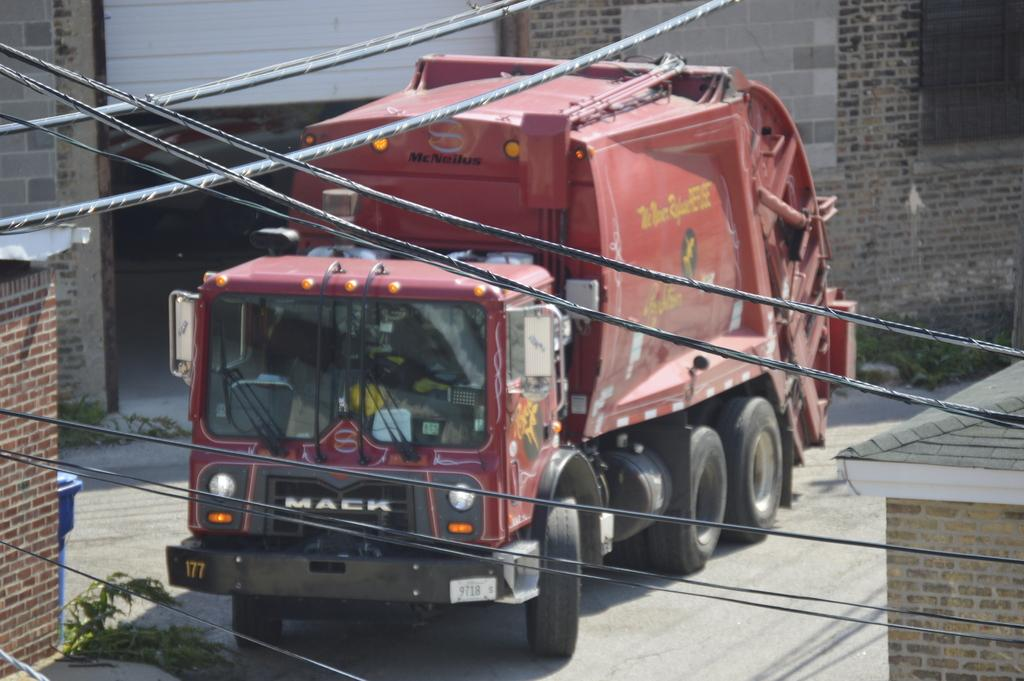What is the main subject of the image? The main subject of the image is a garbage truck. What can be seen in the background of the image? There are buildings around the garbage truck in the background. What object is related to the garbage truck's purpose? There is a trash can in the image. What else is visible at the top of the image? Cables are visible at the top of the image. What type of picture is hanging on the wall of the garbage truck? There is no picture hanging on the wall of the garbage truck in the image. Can you tell me how many cubs are sitting on top of the garbage truck? There are no cubs present in the image. Is there a dog visible in the image? There is no dog visible in the image. 